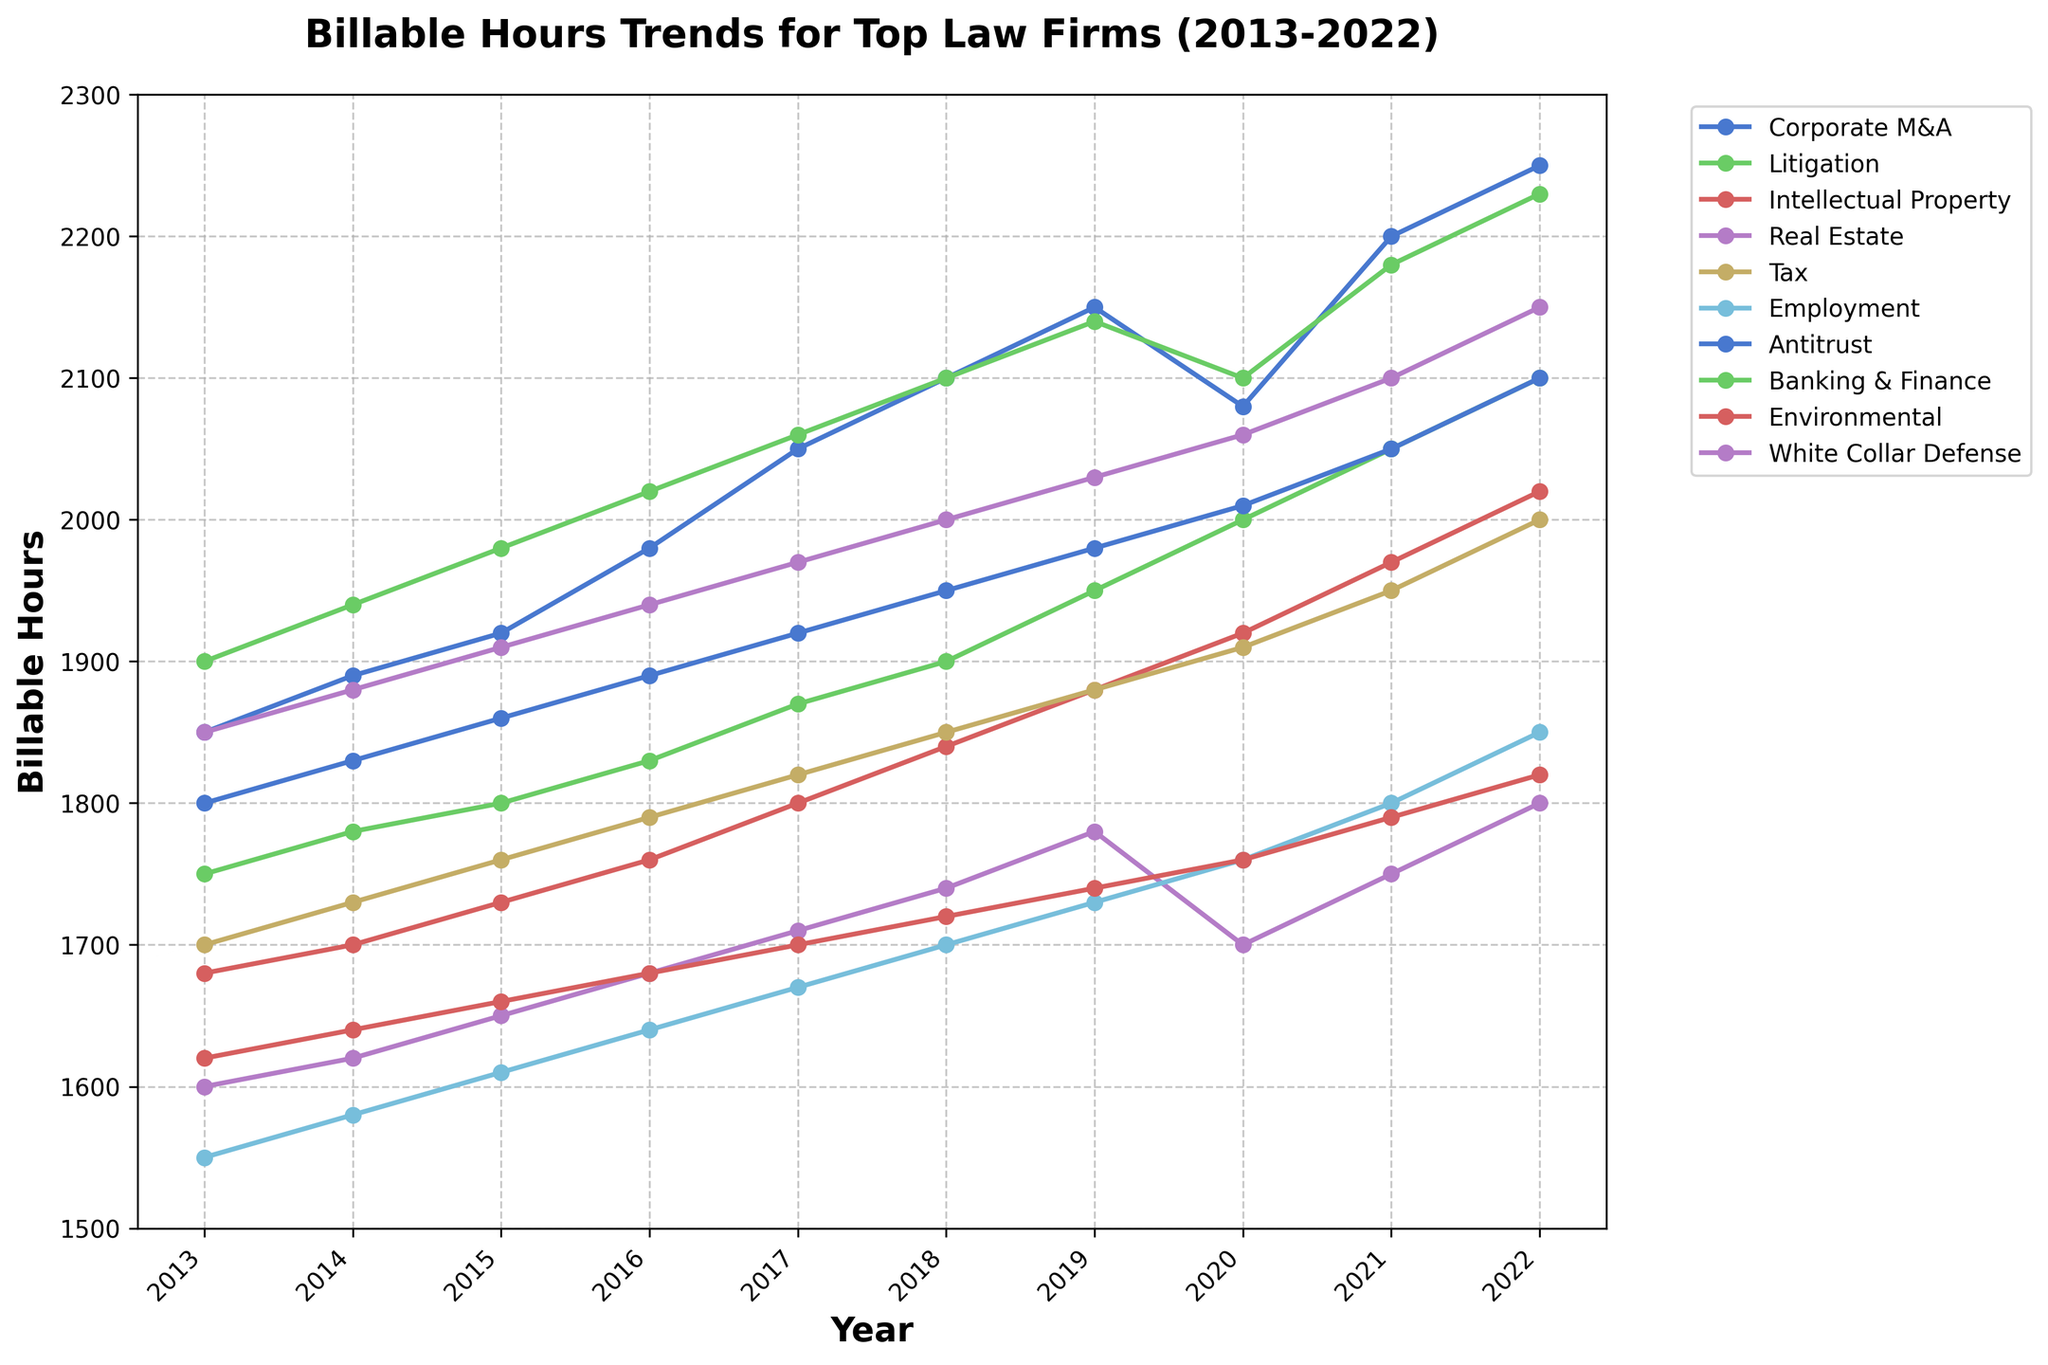What is the trend in billable hours for the Corporate M&A practice area from 2013 to 2022? Start by looking at the line representing the Corporate M&A practice area on the graph. Observe how the billable hours change each year from 2013 to 2022. The trend indicates an overall increase in billable hours over this period.
Answer: Increasing Which practice area had the highest billable hours in 2022? Look for the practice area with the highest point on the vertical axis in the year 2022. The Banking & Finance practice area has the highest billable hours in 2022.
Answer: Banking & Finance Did any practice areas experience a decrease in billable hours in any year? Observe each line carefully to spot any downward trends between two consecutive years. The Real Estate practice area experienced a decrease in billable hours from 2019 to 2020.
Answer: Yes, Real Estate from 2019 to 2020 What is the average increase in billable hours for the Litigation practice area from 2013 to 2022? First, find the billable hours for Litigation in 2013 (1750) and 2022 (2100). The increase is 2100 - 1750 = 350. There are 9 years in between, so the average annual increase is 350 / 9 ≈ 38.89.
Answer: Approximately 38.89 Compare the trends of Intellectual Property and Environmental practice areas. Which one has a steeper increase? Look at the slopes of the lines for Intellectual Property and Environmental practice areas. Calculate the difference in billable hours from 2013 to 2022 for both: IP (2020 - 1680 = 340) and Environmental (1820 - 1620 = 200). Intellectual Property has a steeper increase.
Answer: Intellectual Property Which year had the highest collective billable hours for all practice areas combined? Sum the billable hours for all practice areas for each year: For 2022, the total is 2250 + 2100 + 2020 + 1800 + 2000 + 1850 + 2100 + 2230 + 1820 + 2150 = 20320. Similarly sum for other years. Identifying the highest sum, we find that 2022 had the highest at 20320.
Answer: 2022 What is the difference in the number of billable hours between Antitrust and Tax practice areas in 2020? Check the billable hours for Antitrust in 2020 (2010) and Tax in 2020 (1910). The difference is 2010 - 1910 = 100.
Answer: 100 Which three practice areas had the lowest billable hours in 2018? Find the billable hours for all practice areas in 2018: Identify the three lowest values, which are Real Estate (1740), Environmental (1720), and Employment (1700).
Answer: Real Estate, Environmental, Employment By how much did the billable hours for Corporate M&A increase from 2013 to 2022? Look at the billable hours in 2013 (1850) and 2022 (2250) for Corporate M&A. The increase is 2250 - 1850 = 400.
Answer: 400 